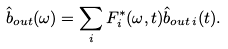Convert formula to latex. <formula><loc_0><loc_0><loc_500><loc_500>\hat { b } _ { o u t } ( \omega ) = \sum _ { i } F _ { i } ^ { \ast } ( \omega , t ) \hat { b } _ { o u t \, i } ( t ) .</formula> 